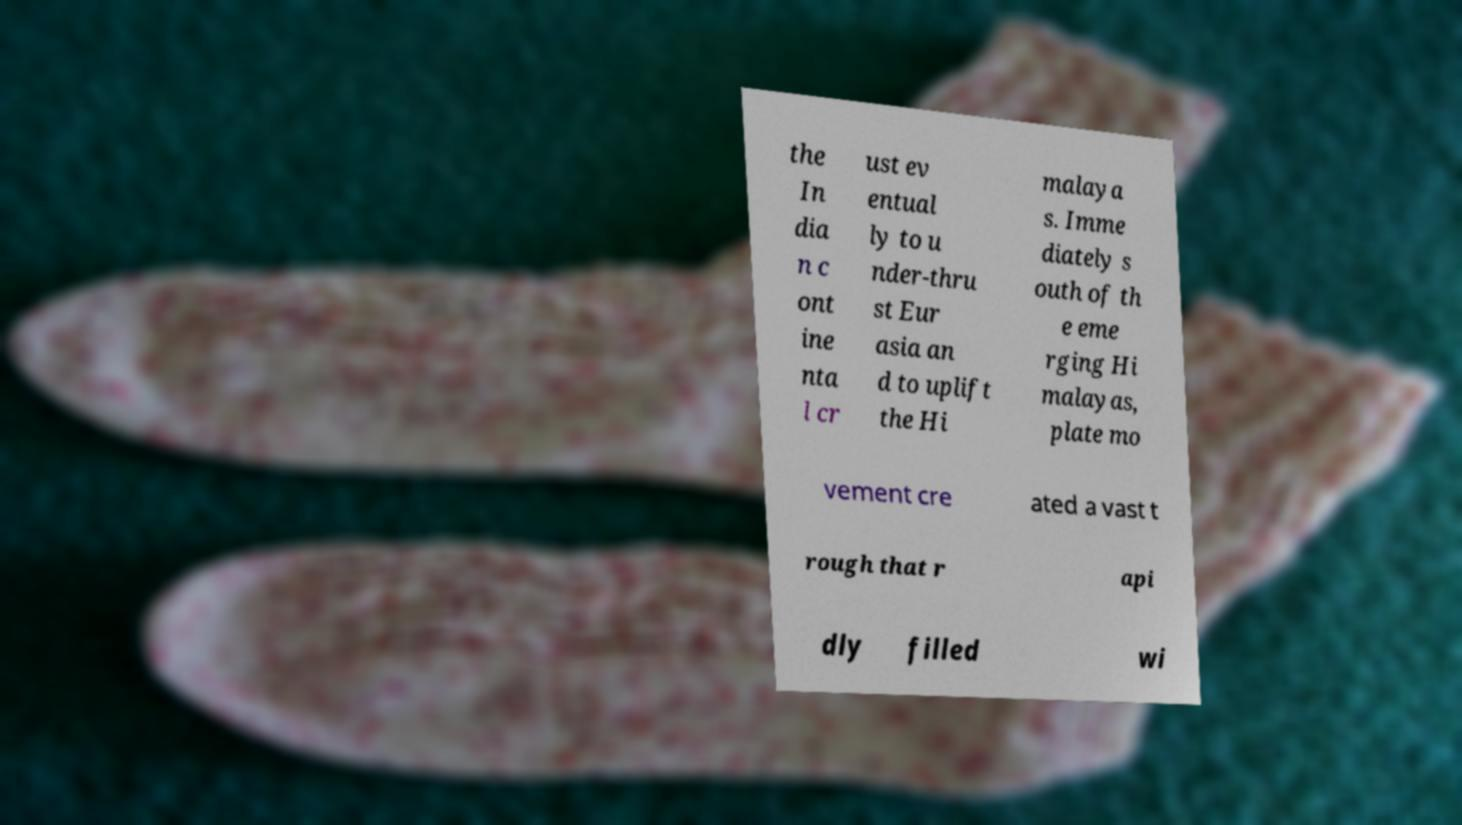Can you accurately transcribe the text from the provided image for me? the In dia n c ont ine nta l cr ust ev entual ly to u nder-thru st Eur asia an d to uplift the Hi malaya s. Imme diately s outh of th e eme rging Hi malayas, plate mo vement cre ated a vast t rough that r api dly filled wi 